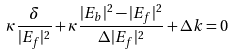<formula> <loc_0><loc_0><loc_500><loc_500>\kappa \frac { \delta } { | E _ { f } | ^ { 2 } } + \kappa \frac { | E _ { b } | ^ { 2 } - | E _ { f } | ^ { 2 } } { \Delta | E _ { f } | ^ { 2 } } + \Delta k = 0</formula> 